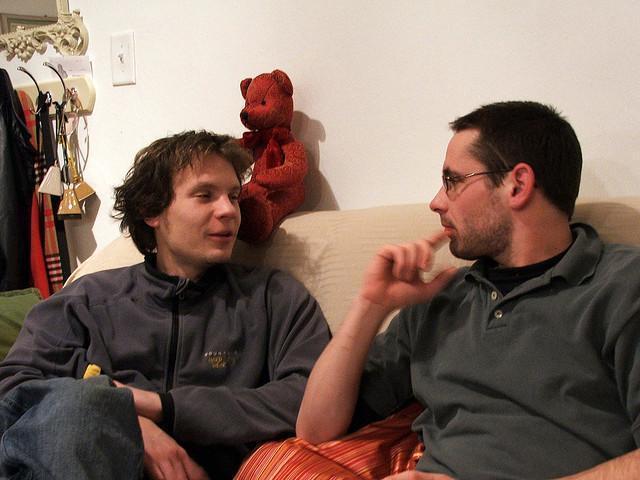How many people are shown?
Give a very brief answer. 2. How many of the men are wearing hats?
Give a very brief answer. 0. How many teddy bears are there?
Give a very brief answer. 1. How many people are there?
Give a very brief answer. 2. 